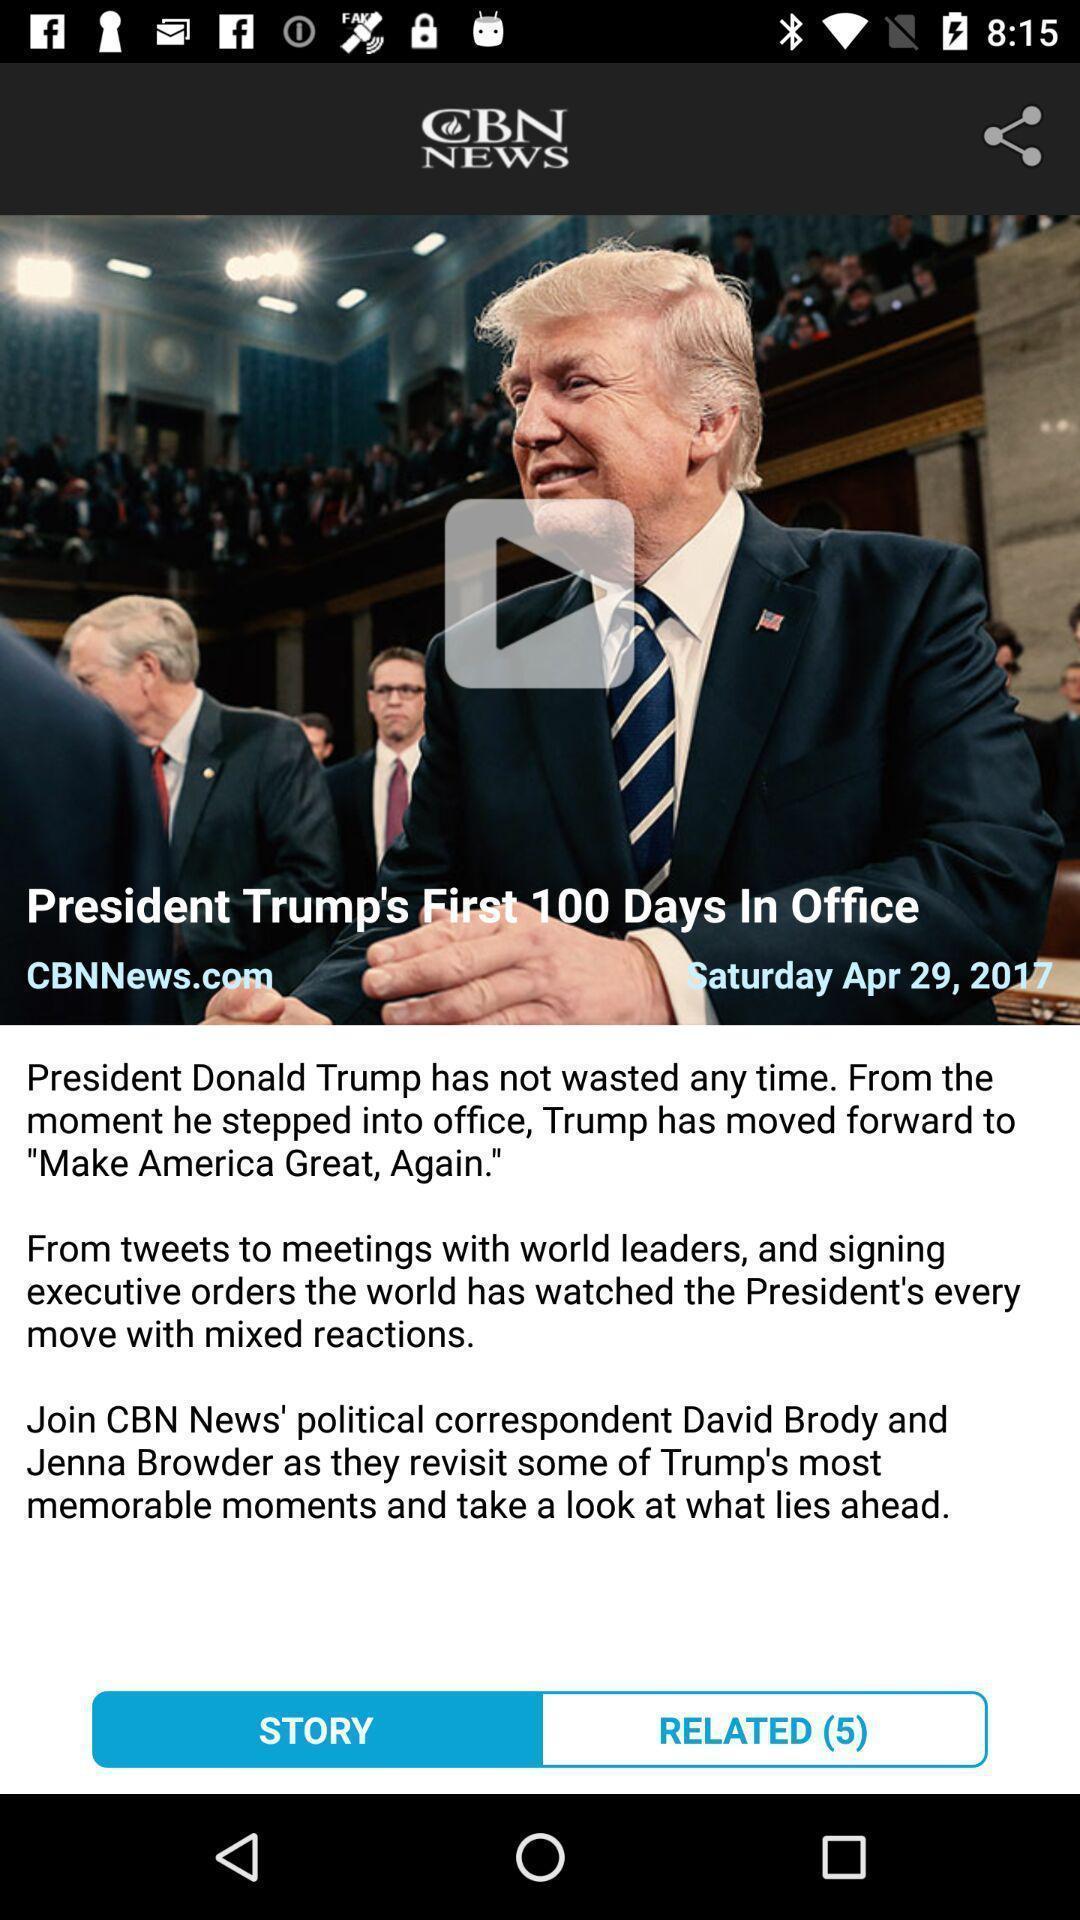Give me a summary of this screen capture. Page showing news story in the news app. 